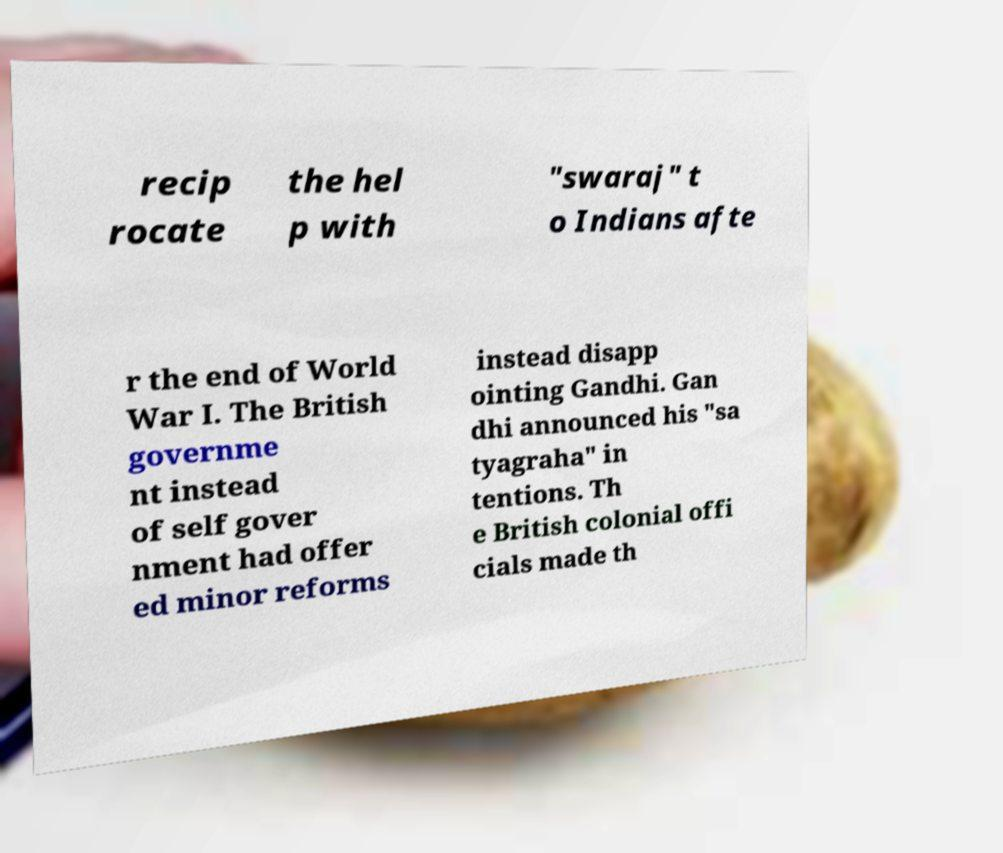I need the written content from this picture converted into text. Can you do that? recip rocate the hel p with "swaraj" t o Indians afte r the end of World War I. The British governme nt instead of self gover nment had offer ed minor reforms instead disapp ointing Gandhi. Gan dhi announced his "sa tyagraha" in tentions. Th e British colonial offi cials made th 